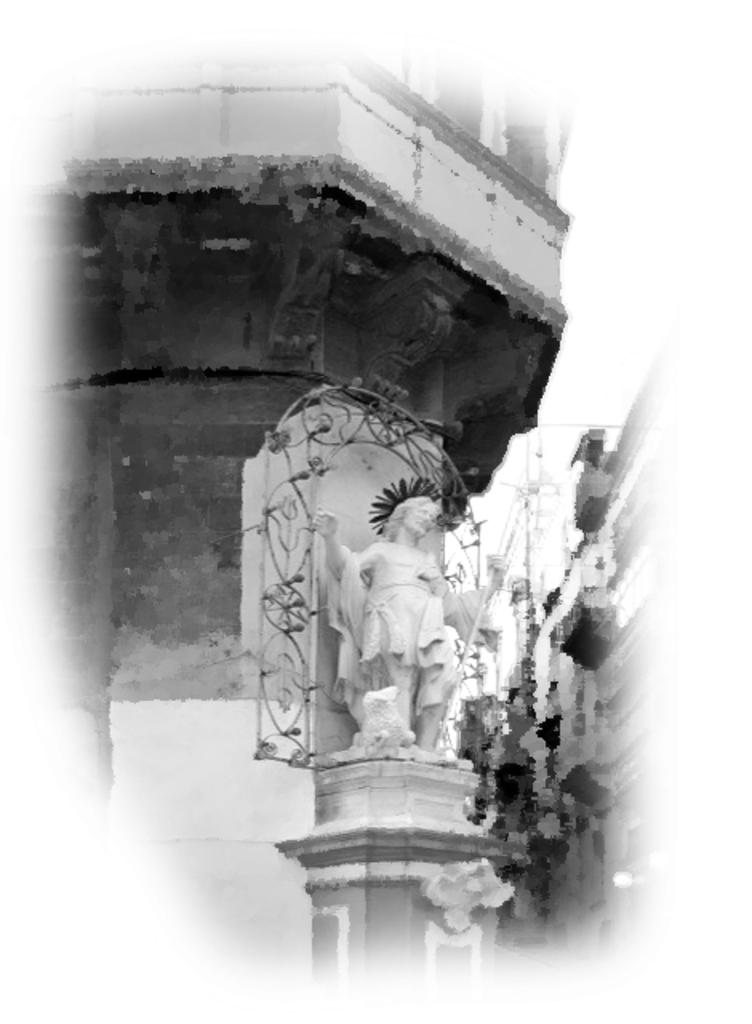What type of structures can be seen in the image? There are buildings in the image. Is there any specific feature in front of a building? Yes, there is a statue in front of a building. What can be seen in the background of the image? The sky is visible in the background of the image. What type of engine is powering the town in the image? There is no town or engine present in the image; it features buildings and a statue. 